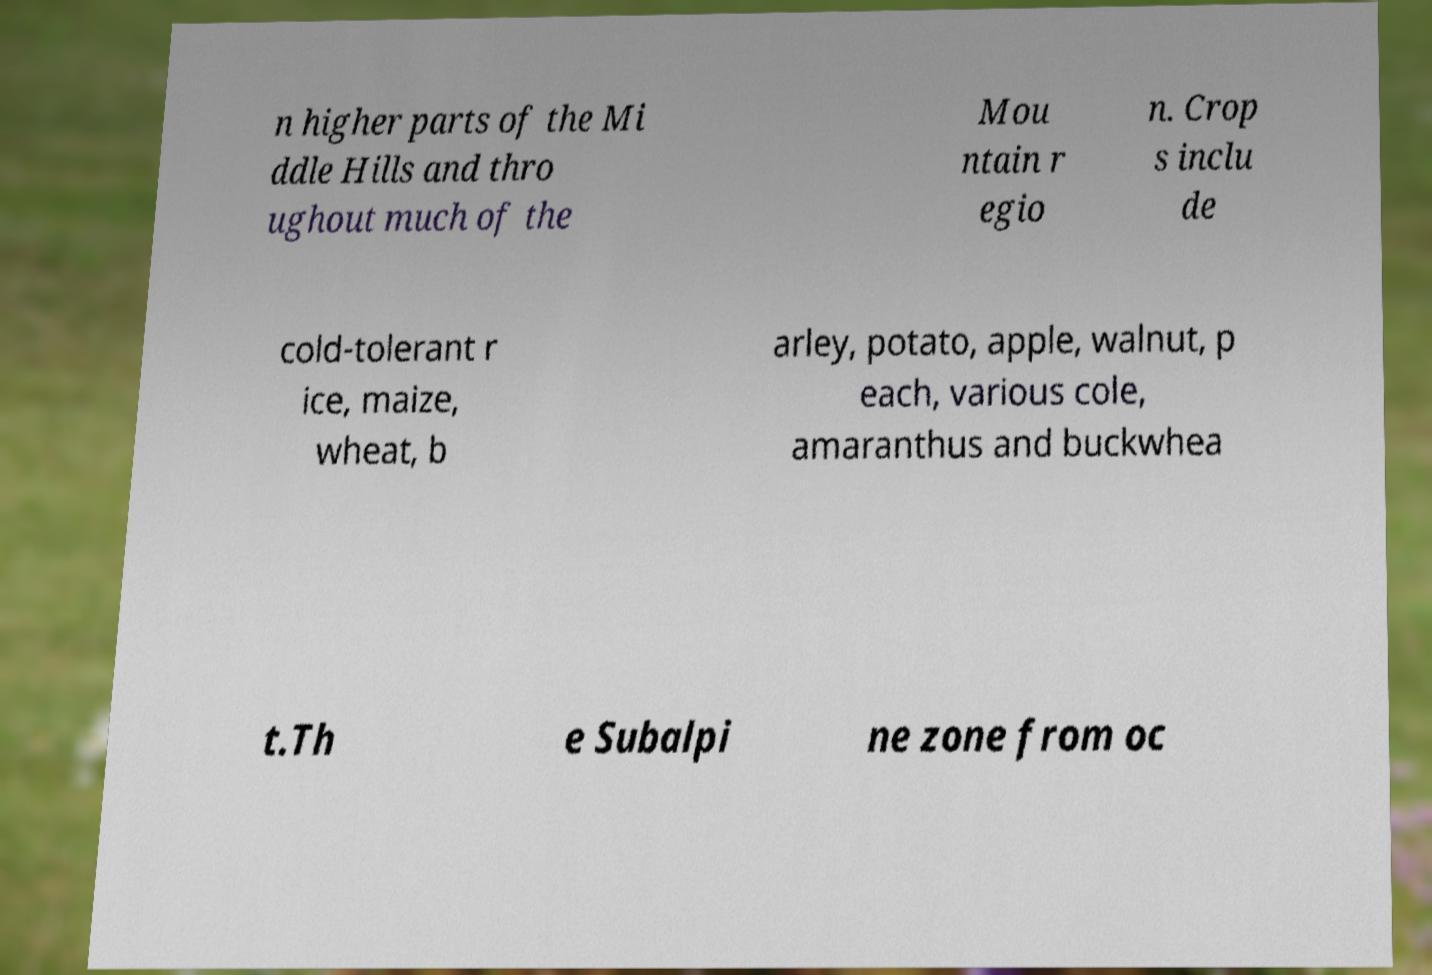Can you accurately transcribe the text from the provided image for me? n higher parts of the Mi ddle Hills and thro ughout much of the Mou ntain r egio n. Crop s inclu de cold-tolerant r ice, maize, wheat, b arley, potato, apple, walnut, p each, various cole, amaranthus and buckwhea t.Th e Subalpi ne zone from oc 